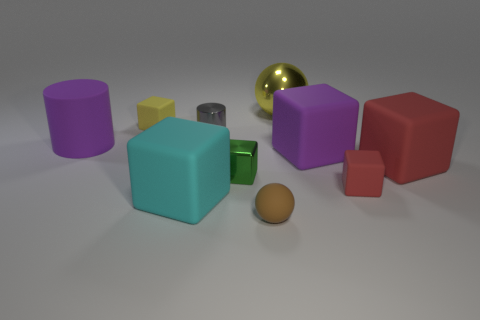Subtract all green cubes. How many cubes are left? 5 Subtract all brown balls. How many red cubes are left? 2 Subtract all cyan blocks. How many blocks are left? 5 Subtract all cylinders. How many objects are left? 8 Subtract all big blue metal blocks. Subtract all gray shiny things. How many objects are left? 9 Add 3 tiny spheres. How many tiny spheres are left? 4 Add 3 large yellow shiny objects. How many large yellow shiny objects exist? 4 Subtract 0 green cylinders. How many objects are left? 10 Subtract all blue blocks. Subtract all yellow cylinders. How many blocks are left? 6 